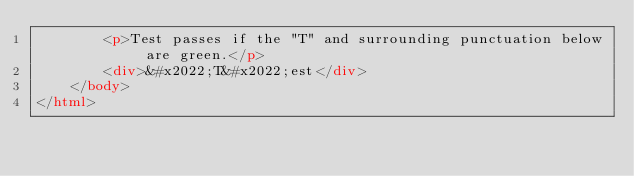<code> <loc_0><loc_0><loc_500><loc_500><_HTML_>        <p>Test passes if the "T" and surrounding punctuation below are green.</p>
        <div>&#x2022;T&#x2022;est</div>
    </body>
</html>
</code> 